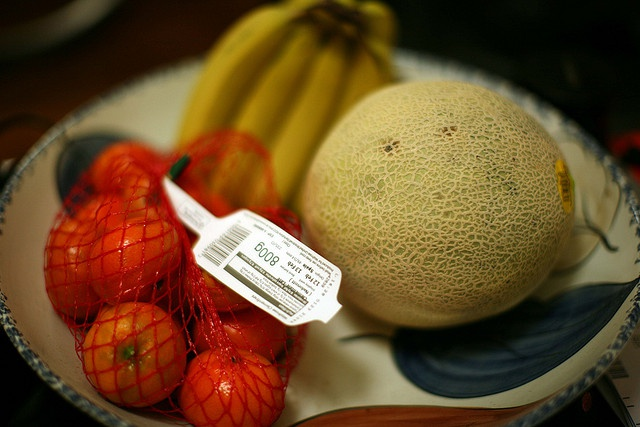Describe the objects in this image and their specific colors. I can see bowl in black, olive, tan, and maroon tones, banana in black and olive tones, orange in black, brown, maroon, and red tones, orange in black, maroon, and brown tones, and orange in black, maroon, and red tones in this image. 